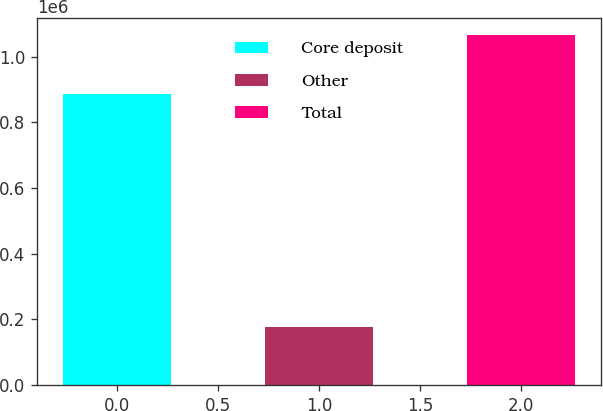<chart> <loc_0><loc_0><loc_500><loc_500><bar_chart><fcel>Core deposit<fcel>Other<fcel>Total<nl><fcel>887459<fcel>177268<fcel>1.06473e+06<nl></chart> 